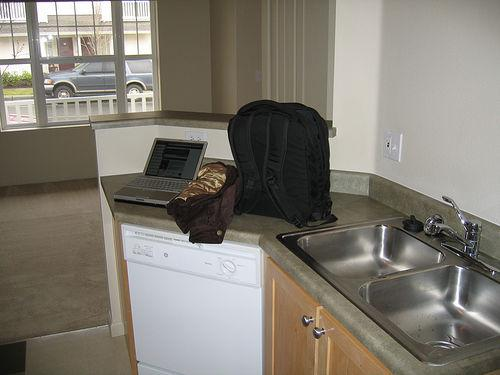Where is someone working? Please explain your reasoning. home. The laptop and bag are on a counter in a house. 